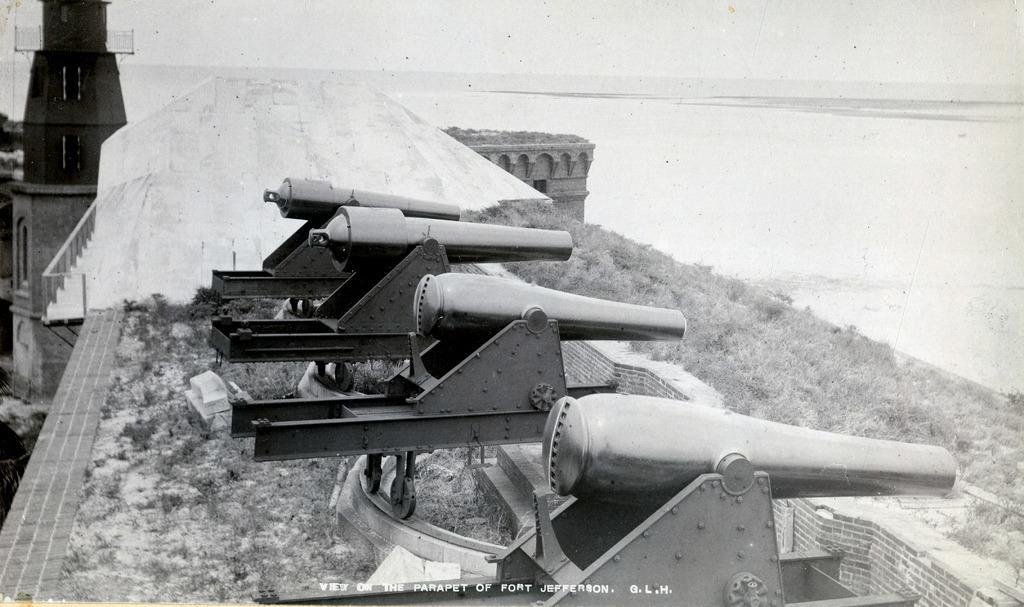Please provide a concise description of this image. In this image there are a few cannon guns on top of the fort, beside the guns there is the fort, grass and some text at the bottom. 